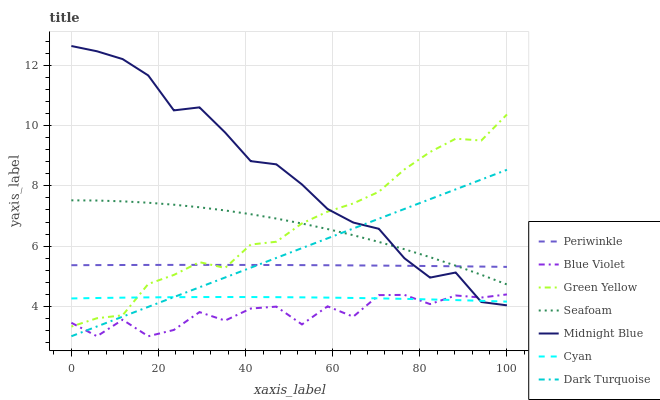Does Dark Turquoise have the minimum area under the curve?
Answer yes or no. No. Does Dark Turquoise have the maximum area under the curve?
Answer yes or no. No. Is Seafoam the smoothest?
Answer yes or no. No. Is Seafoam the roughest?
Answer yes or no. No. Does Seafoam have the lowest value?
Answer yes or no. No. Does Dark Turquoise have the highest value?
Answer yes or no. No. Is Cyan less than Periwinkle?
Answer yes or no. Yes. Is Periwinkle greater than Blue Violet?
Answer yes or no. Yes. Does Cyan intersect Periwinkle?
Answer yes or no. No. 